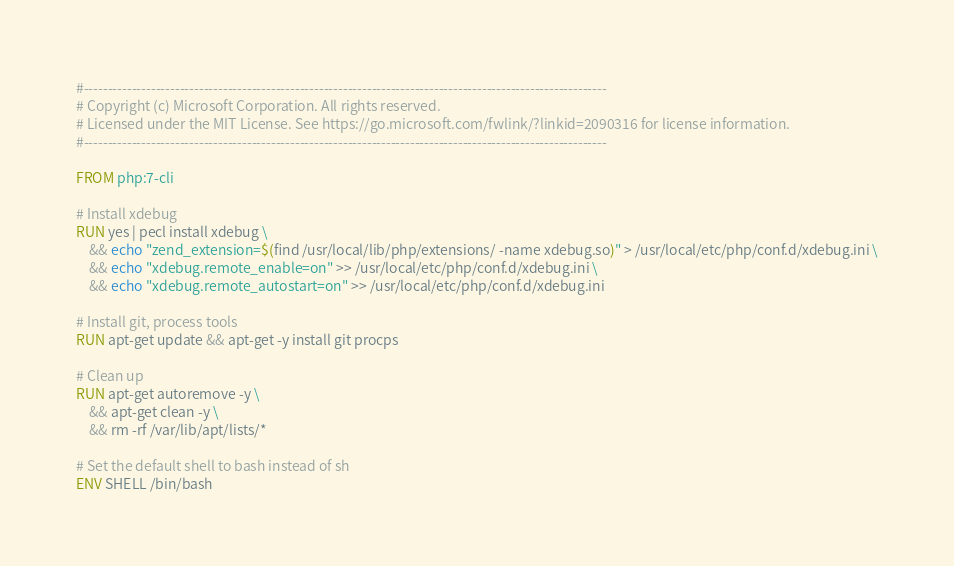<code> <loc_0><loc_0><loc_500><loc_500><_Dockerfile_>#-------------------------------------------------------------------------------------------------------------
# Copyright (c) Microsoft Corporation. All rights reserved.
# Licensed under the MIT License. See https://go.microsoft.com/fwlink/?linkid=2090316 for license information.
#-------------------------------------------------------------------------------------------------------------

FROM php:7-cli

# Install xdebug
RUN yes | pecl install xdebug \
	&& echo "zend_extension=$(find /usr/local/lib/php/extensions/ -name xdebug.so)" > /usr/local/etc/php/conf.d/xdebug.ini \
	&& echo "xdebug.remote_enable=on" >> /usr/local/etc/php/conf.d/xdebug.ini \
	&& echo "xdebug.remote_autostart=on" >> /usr/local/etc/php/conf.d/xdebug.ini

# Install git, process tools
RUN apt-get update && apt-get -y install git procps

# Clean up
RUN apt-get autoremove -y \
    && apt-get clean -y \
    && rm -rf /var/lib/apt/lists/*

# Set the default shell to bash instead of sh
ENV SHELL /bin/bash

</code> 